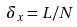<formula> <loc_0><loc_0><loc_500><loc_500>\delta _ { x } = L / N</formula> 